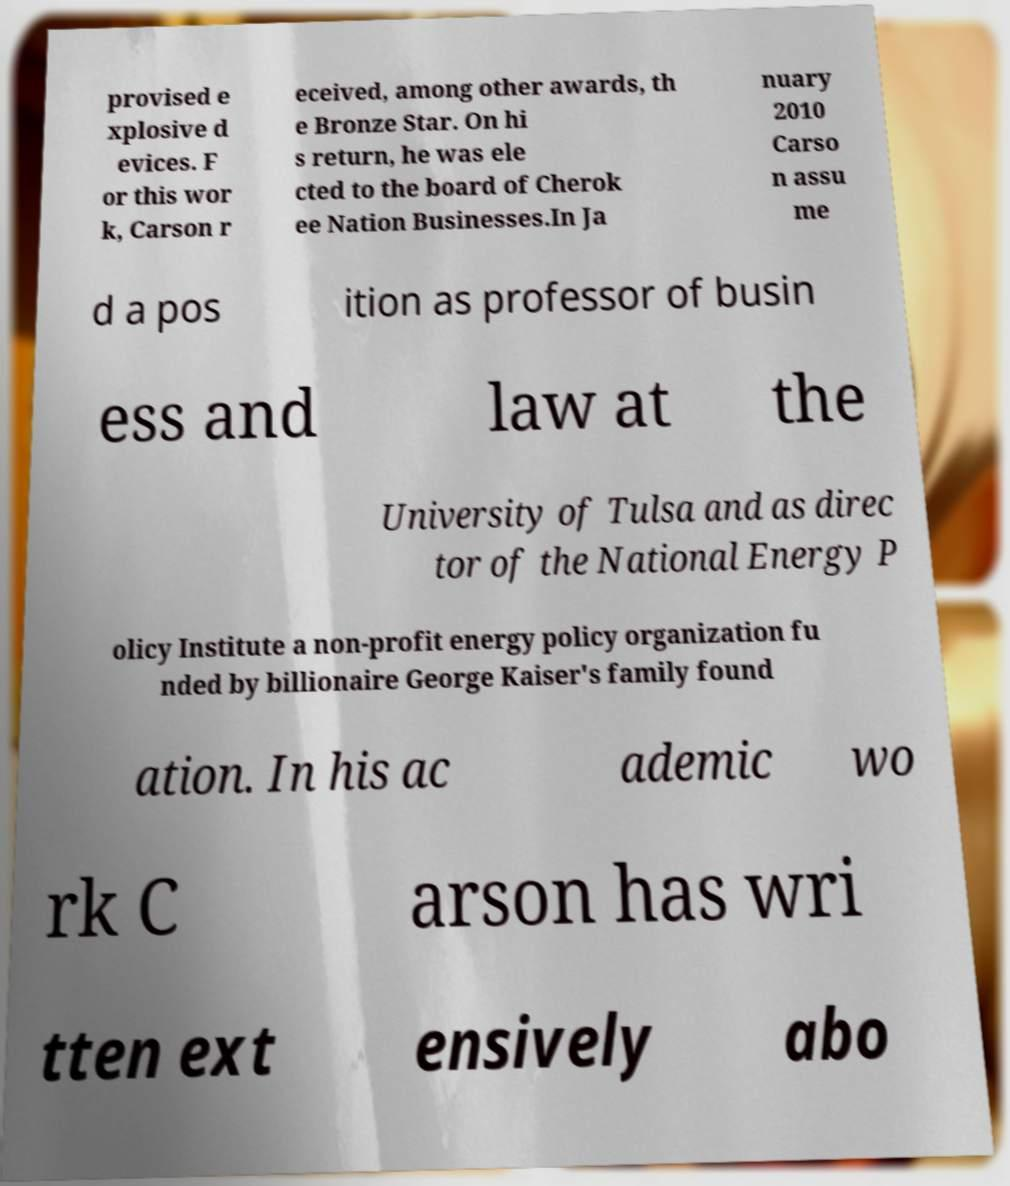There's text embedded in this image that I need extracted. Can you transcribe it verbatim? provised e xplosive d evices. F or this wor k, Carson r eceived, among other awards, th e Bronze Star. On hi s return, he was ele cted to the board of Cherok ee Nation Businesses.In Ja nuary 2010 Carso n assu me d a pos ition as professor of busin ess and law at the University of Tulsa and as direc tor of the National Energy P olicy Institute a non-profit energy policy organization fu nded by billionaire George Kaiser's family found ation. In his ac ademic wo rk C arson has wri tten ext ensively abo 